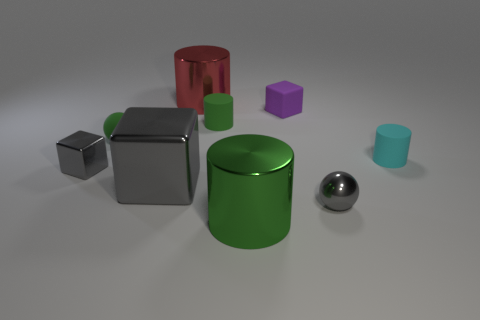Subtract all gray cylinders. Subtract all red balls. How many cylinders are left? 4 Add 1 small red shiny objects. How many objects exist? 10 Subtract all cylinders. How many objects are left? 5 Subtract all red rubber objects. Subtract all large blocks. How many objects are left? 8 Add 7 blocks. How many blocks are left? 10 Add 1 tiny rubber blocks. How many tiny rubber blocks exist? 2 Subtract 0 purple cylinders. How many objects are left? 9 